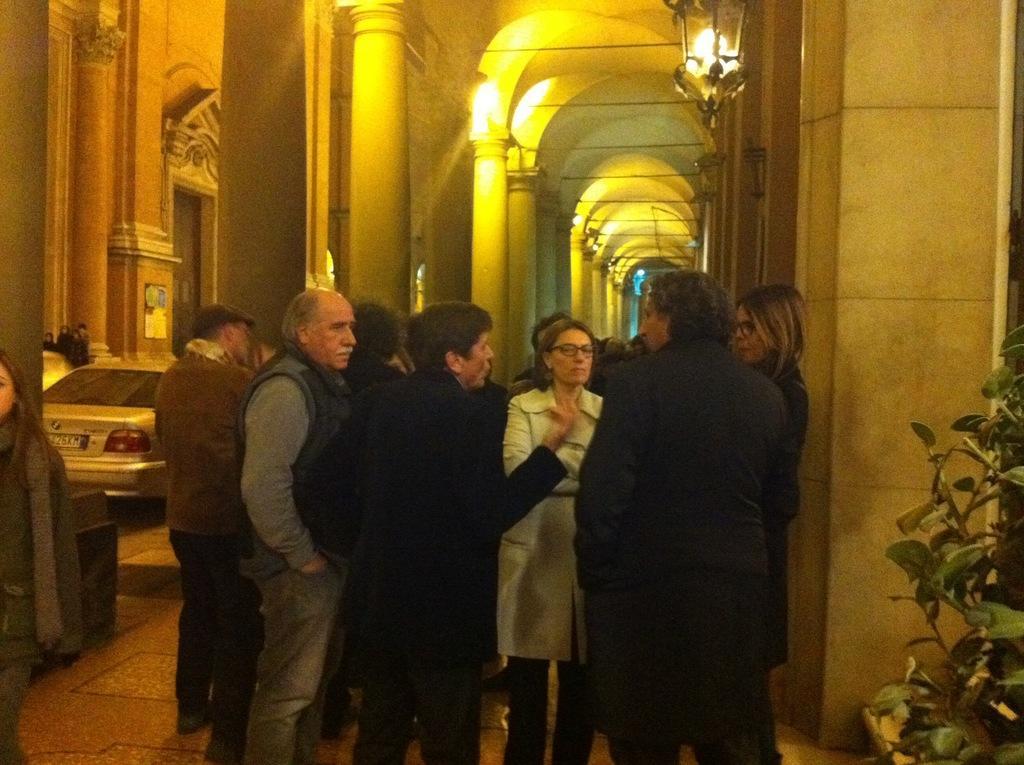Can you describe this image briefly? In this image in the front there are group of persons standing. On the right side there are leaves. On the left side there is a car and there is a door and there are persons. In the background there are pillars and there are lights. 